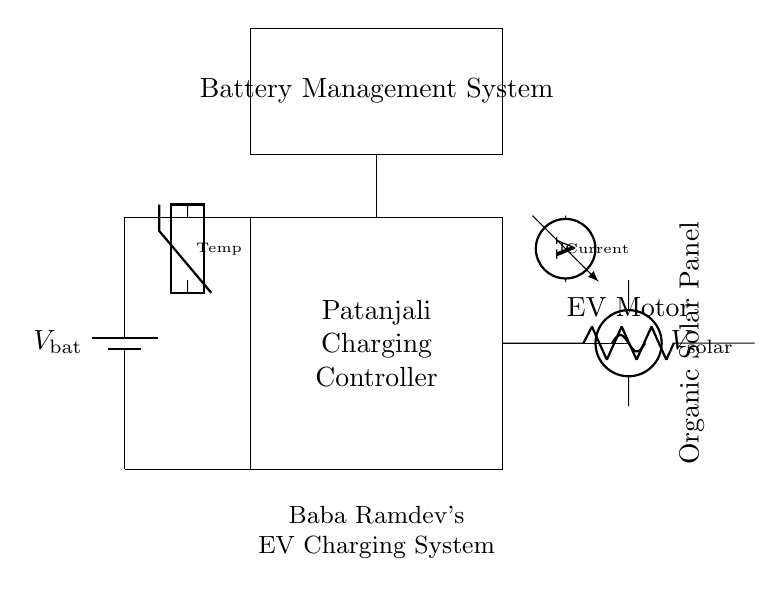What is the main component that regulates charging? The main component that regulates charging in the circuit is the Patanjali Charging Controller, which is specifically designed to manage electricity from the solar panel to the battery.
Answer: Patanjali Charging Controller What is the source of energy for the battery? The energy source for the battery is the Organic Solar Panel, which converts sunlight into electrical energy.
Answer: Organic Solar Panel Which component measures current? The current is measured by the ammeter, which provides readings on the amount of electric current flowing through the circuit.
Answer: Ammeter What type of load is represented in the circuit? The load represented in the circuit is the EV Motor, which is responsible for driving the electric vehicle.
Answer: EV Motor How many components are involved in temperature monitoring? There is one component involved in temperature monitoring, which is the thermistor designed to detect temperature changes in the battery management system.
Answer: One What is the connection between the battery and the charging controller? The battery and the charging controller are connected directly with a wire, indicating that the controller manages the charge being fed to the battery from the solar panel.
Answer: Direct wire connection What is the role of the Battery Management System? The role of the Battery Management System is to oversee and control the charging process, ensuring that the battery maintains its health and operates safely.
Answer: Overseeing charging process 